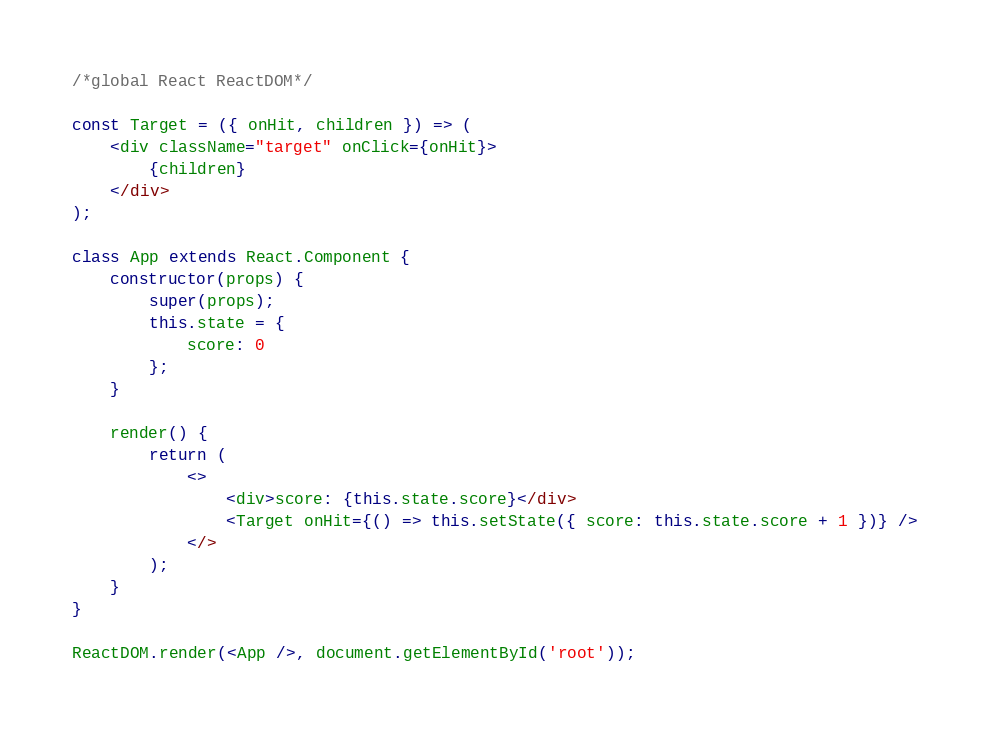Convert code to text. <code><loc_0><loc_0><loc_500><loc_500><_JavaScript_>/*global React ReactDOM*/

const Target = ({ onHit, children }) => (
	<div className="target" onClick={onHit}>
		{children}
	</div>
);

class App extends React.Component {
	constructor(props) {
		super(props);
		this.state = {
			score: 0
		};
	}

	render() {
		return (
			<>
				<div>score: {this.state.score}</div>
				<Target onHit={() => this.setState({ score: this.state.score + 1 })} />
			</>
		);
	}
}

ReactDOM.render(<App />, document.getElementById('root'));
</code> 